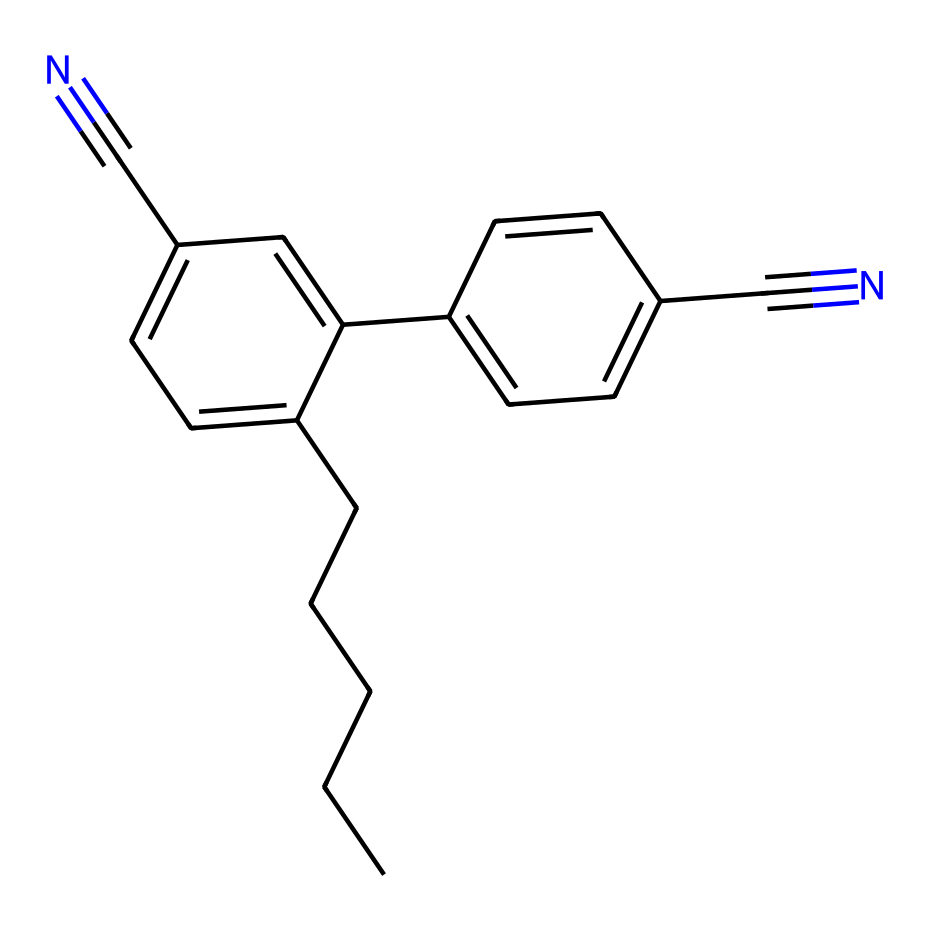What is the molecular formula of the compound represented by the SMILES? To determine the molecular formula, count the number of each type of atom present in the SMILES string. The structure contains carbon (C), hydrogen (H), and nitrogen (N) atoms. By analyzing the SMILES, there are 14 carbon atoms, 11 hydrogen atoms, and 2 nitrogen atoms, leading to the molecular formula C14H11N2.
Answer: C14H11N2 How many rings are present in the structure? By examining the SMILES notation, we can see the presence of numbers indicating ring closures (the numbers represent points where carbon atoms are connected in a ring). There are two instances of ring closure (with the numbers '1' and '2'), indicating that there are 2 rings in the structure.
Answer: 2 What is the significance of the cyano groups in this liquid crystal material? The cyano groups (C#N) are important for the liquid crystal properties of this material. They improve the thermal stability and allow for the manipulation of the liquid crystal phases, which are crucial for display technologies.
Answer: improve stability What type of bonding is predominantly present in this compound? In this structure, covalent bonding is predominant as all atoms are connected through shared electrons (specifically between carbon, nitrogen, and hydrogen atoms). This is typical for organic compounds like this one.
Answer: covalent How does the presence of multiple aromatic rings affect the optical properties of the material? The multiple aromatic rings contribute to the delocalization of π-electrons, which impacts the absorption and emission of light. This delocalization enhances the optical transition properties, making it suitable for use in displays.
Answer: enhances optical transition What are the hydrophobic characteristics of this compound based on its structure? The presence of a long carbon chain (CCCCCC) suggests that this compound has hydrophobic characteristics due to the non-polar nature of long hydrocarbon chains, which typically do not interact favorably with water.
Answer: hydrophobic How many total double bonds are present in the molecular structure? By inspecting the structure represented in the SMILES, we note that there are 3 instances of double bonds (specifically between carbon atoms), signifying a total of 3 double bonds in the molecule.
Answer: 3 